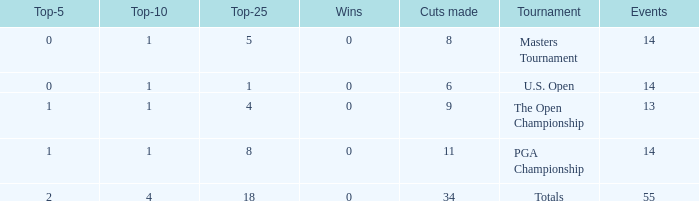What is the average top-5 when the cuts made is more than 34? None. 